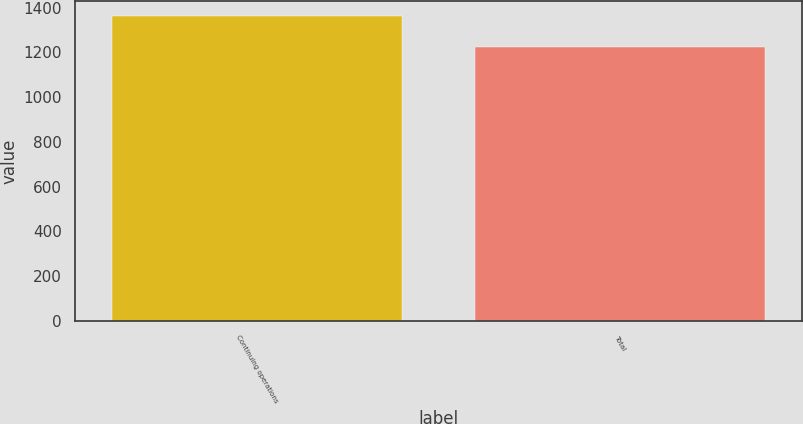Convert chart. <chart><loc_0><loc_0><loc_500><loc_500><bar_chart><fcel>Continuing operations<fcel>Total<nl><fcel>1362<fcel>1226<nl></chart> 